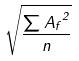<formula> <loc_0><loc_0><loc_500><loc_500>\sqrt { \frac { \sum { A _ { f } } ^ { 2 } } { n } }</formula> 